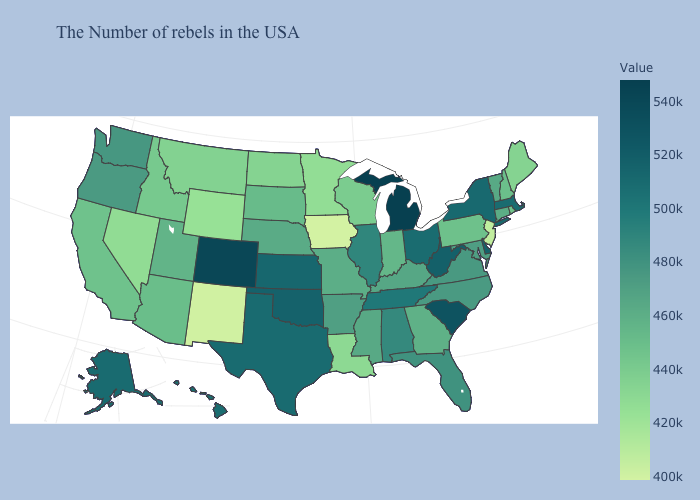Does Virginia have a lower value than California?
Give a very brief answer. No. Among the states that border Iowa , which have the highest value?
Answer briefly. Illinois. Does Michigan have the highest value in the USA?
Short answer required. Yes. Does New Jersey have the lowest value in the Northeast?
Keep it brief. Yes. Among the states that border Colorado , does Oklahoma have the lowest value?
Concise answer only. No. Among the states that border Kansas , which have the lowest value?
Write a very short answer. Missouri. Does the map have missing data?
Write a very short answer. No. Which states have the lowest value in the Northeast?
Answer briefly. New Jersey. 